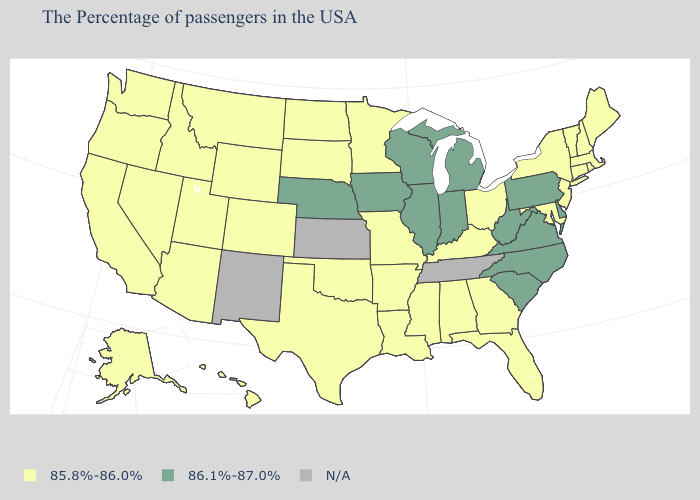What is the value of Maryland?
Write a very short answer. 85.8%-86.0%. Name the states that have a value in the range 86.1%-87.0%?
Answer briefly. Delaware, Pennsylvania, Virginia, North Carolina, South Carolina, West Virginia, Michigan, Indiana, Wisconsin, Illinois, Iowa, Nebraska. What is the value of North Carolina?
Be succinct. 86.1%-87.0%. What is the value of Montana?
Write a very short answer. 85.8%-86.0%. Name the states that have a value in the range 86.1%-87.0%?
Short answer required. Delaware, Pennsylvania, Virginia, North Carolina, South Carolina, West Virginia, Michigan, Indiana, Wisconsin, Illinois, Iowa, Nebraska. What is the value of Mississippi?
Answer briefly. 85.8%-86.0%. Among the states that border West Virginia , which have the lowest value?
Give a very brief answer. Maryland, Ohio, Kentucky. What is the value of Michigan?
Keep it brief. 86.1%-87.0%. What is the highest value in states that border California?
Answer briefly. 85.8%-86.0%. Which states have the lowest value in the USA?
Write a very short answer. Maine, Massachusetts, Rhode Island, New Hampshire, Vermont, Connecticut, New York, New Jersey, Maryland, Ohio, Florida, Georgia, Kentucky, Alabama, Mississippi, Louisiana, Missouri, Arkansas, Minnesota, Oklahoma, Texas, South Dakota, North Dakota, Wyoming, Colorado, Utah, Montana, Arizona, Idaho, Nevada, California, Washington, Oregon, Alaska, Hawaii. Name the states that have a value in the range 85.8%-86.0%?
Quick response, please. Maine, Massachusetts, Rhode Island, New Hampshire, Vermont, Connecticut, New York, New Jersey, Maryland, Ohio, Florida, Georgia, Kentucky, Alabama, Mississippi, Louisiana, Missouri, Arkansas, Minnesota, Oklahoma, Texas, South Dakota, North Dakota, Wyoming, Colorado, Utah, Montana, Arizona, Idaho, Nevada, California, Washington, Oregon, Alaska, Hawaii. Does Idaho have the highest value in the USA?
Write a very short answer. No. What is the lowest value in states that border New Hampshire?
Short answer required. 85.8%-86.0%. Does the first symbol in the legend represent the smallest category?
Short answer required. Yes. What is the highest value in the USA?
Answer briefly. 86.1%-87.0%. 